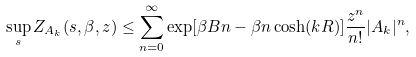<formula> <loc_0><loc_0><loc_500><loc_500>\sup _ { s } Z _ { A _ { k } } ( s , \beta , z ) \leq \sum _ { n = 0 } ^ { \infty } \exp [ \beta B n - \beta n \cosh ( k R ) ] \frac { z ^ { n } } { n ! } | A _ { k } | ^ { n } ,</formula> 